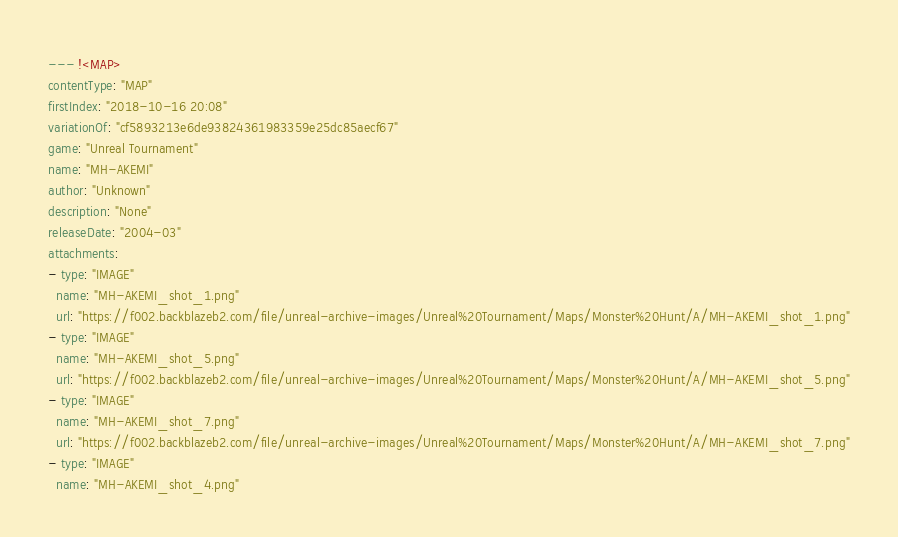<code> <loc_0><loc_0><loc_500><loc_500><_YAML_>--- !<MAP>
contentType: "MAP"
firstIndex: "2018-10-16 20:08"
variationOf: "cf5893213e6de93824361983359e25dc85aecf67"
game: "Unreal Tournament"
name: "MH-AKEMI"
author: "Unknown"
description: "None"
releaseDate: "2004-03"
attachments:
- type: "IMAGE"
  name: "MH-AKEMI_shot_1.png"
  url: "https://f002.backblazeb2.com/file/unreal-archive-images/Unreal%20Tournament/Maps/Monster%20Hunt/A/MH-AKEMI_shot_1.png"
- type: "IMAGE"
  name: "MH-AKEMI_shot_5.png"
  url: "https://f002.backblazeb2.com/file/unreal-archive-images/Unreal%20Tournament/Maps/Monster%20Hunt/A/MH-AKEMI_shot_5.png"
- type: "IMAGE"
  name: "MH-AKEMI_shot_7.png"
  url: "https://f002.backblazeb2.com/file/unreal-archive-images/Unreal%20Tournament/Maps/Monster%20Hunt/A/MH-AKEMI_shot_7.png"
- type: "IMAGE"
  name: "MH-AKEMI_shot_4.png"</code> 